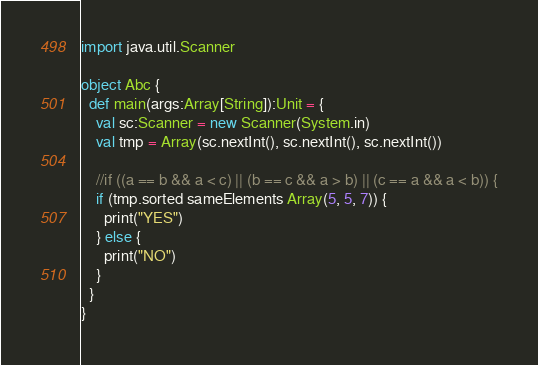Convert code to text. <code><loc_0><loc_0><loc_500><loc_500><_Scala_>import java.util.Scanner
 
object Abc {
  def main(args:Array[String]):Unit = {
    val sc:Scanner = new Scanner(System.in)
    val tmp = Array(sc.nextInt(), sc.nextInt(), sc.nextInt())
 
    //if ((a == b && a < c) || (b == c && a > b) || (c == a && a < b)) {
    if (tmp.sorted sameElements Array(5, 5, 7)) {
      print("YES")
    } else {
      print("NO")
    }
  }
}</code> 